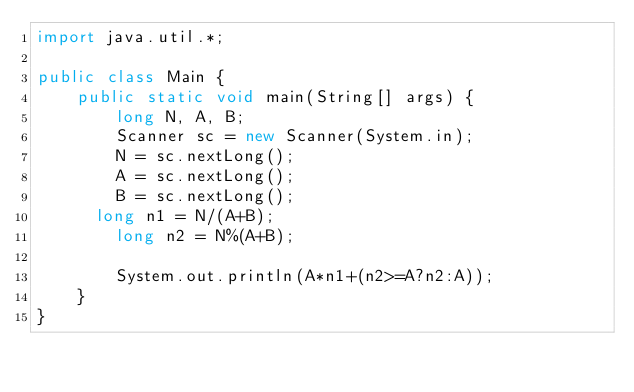<code> <loc_0><loc_0><loc_500><loc_500><_Java_>import java.util.*;
 
public class Main {
    public static void main(String[] args) {
        long N, A, B;
        Scanner sc = new Scanner(System.in);
        N = sc.nextLong();
        A = sc.nextLong();
        B = sc.nextLong();
      long n1 = N/(A+B);
        long n2 = N%(A+B);
        
        System.out.println(A*n1+(n2>=A?n2:A));
    }
}</code> 